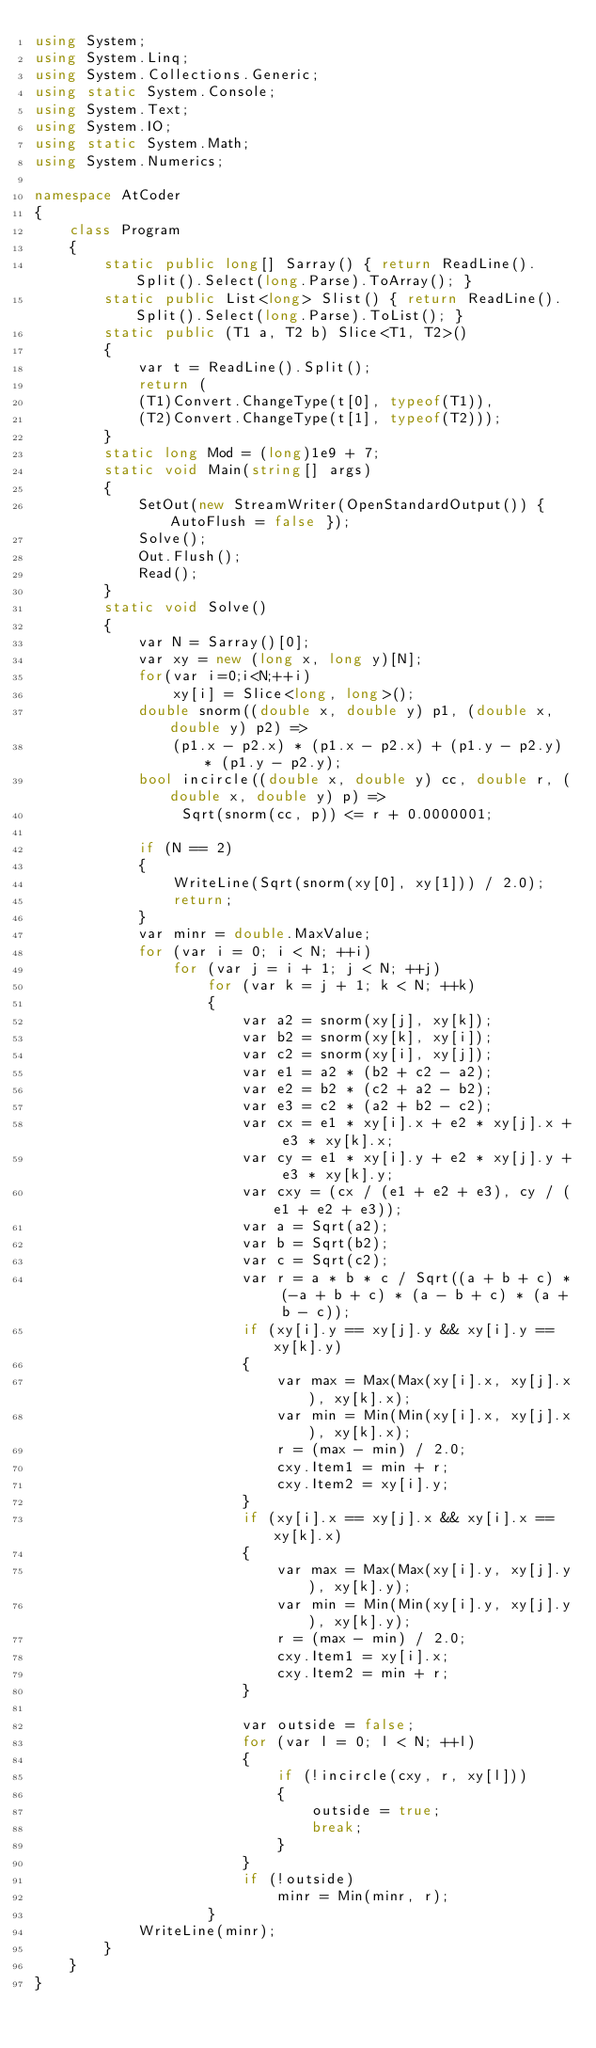Convert code to text. <code><loc_0><loc_0><loc_500><loc_500><_C#_>using System;
using System.Linq;
using System.Collections.Generic;
using static System.Console;
using System.Text;
using System.IO;
using static System.Math;
using System.Numerics;

namespace AtCoder
{
    class Program
    {
        static public long[] Sarray() { return ReadLine().Split().Select(long.Parse).ToArray(); }
        static public List<long> Slist() { return ReadLine().Split().Select(long.Parse).ToList(); }
        static public (T1 a, T2 b) Slice<T1, T2>()
        {
            var t = ReadLine().Split();
            return (
            (T1)Convert.ChangeType(t[0], typeof(T1)),
            (T2)Convert.ChangeType(t[1], typeof(T2)));
        }
        static long Mod = (long)1e9 + 7;
        static void Main(string[] args)
        {
            SetOut(new StreamWriter(OpenStandardOutput()) { AutoFlush = false });
            Solve();
            Out.Flush();
            Read();
        }
        static void Solve()
        {
            var N = Sarray()[0];
            var xy = new (long x, long y)[N];
            for(var i=0;i<N;++i)
                xy[i] = Slice<long, long>();
            double snorm((double x, double y) p1, (double x, double y) p2) =>
                (p1.x - p2.x) * (p1.x - p2.x) + (p1.y - p2.y) * (p1.y - p2.y);
            bool incircle((double x, double y) cc, double r, (double x, double y) p) =>
                 Sqrt(snorm(cc, p)) <= r + 0.0000001;

            if (N == 2)
            {
                WriteLine(Sqrt(snorm(xy[0], xy[1])) / 2.0);
                return;
            }
            var minr = double.MaxValue;
            for (var i = 0; i < N; ++i)
                for (var j = i + 1; j < N; ++j)
                    for (var k = j + 1; k < N; ++k)
                    {
                        var a2 = snorm(xy[j], xy[k]);
                        var b2 = snorm(xy[k], xy[i]);
                        var c2 = snorm(xy[i], xy[j]);
                        var e1 = a2 * (b2 + c2 - a2);
                        var e2 = b2 * (c2 + a2 - b2);
                        var e3 = c2 * (a2 + b2 - c2);
                        var cx = e1 * xy[i].x + e2 * xy[j].x + e3 * xy[k].x;
                        var cy = e1 * xy[i].y + e2 * xy[j].y + e3 * xy[k].y;
                        var cxy = (cx / (e1 + e2 + e3), cy / (e1 + e2 + e3));
                        var a = Sqrt(a2);
                        var b = Sqrt(b2);
                        var c = Sqrt(c2);
                        var r = a * b * c / Sqrt((a + b + c) * (-a + b + c) * (a - b + c) * (a + b - c));
                        if (xy[i].y == xy[j].y && xy[i].y == xy[k].y)
                        {
                            var max = Max(Max(xy[i].x, xy[j].x), xy[k].x);
                            var min = Min(Min(xy[i].x, xy[j].x), xy[k].x);
                            r = (max - min) / 2.0;
                            cxy.Item1 = min + r;
                            cxy.Item2 = xy[i].y;
                        }
                        if (xy[i].x == xy[j].x && xy[i].x == xy[k].x)
                        {
                            var max = Max(Max(xy[i].y, xy[j].y), xy[k].y);
                            var min = Min(Min(xy[i].y, xy[j].y), xy[k].y);
                            r = (max - min) / 2.0;
                            cxy.Item1 = xy[i].x;
                            cxy.Item2 = min + r;
                        }

                        var outside = false;
                        for (var l = 0; l < N; ++l)
                        {
                            if (!incircle(cxy, r, xy[l]))
                            {
                                outside = true;
                                break;
                            }
                        }
                        if (!outside)
                            minr = Min(minr, r);
                    }
            WriteLine(minr);
        }
    }
}</code> 